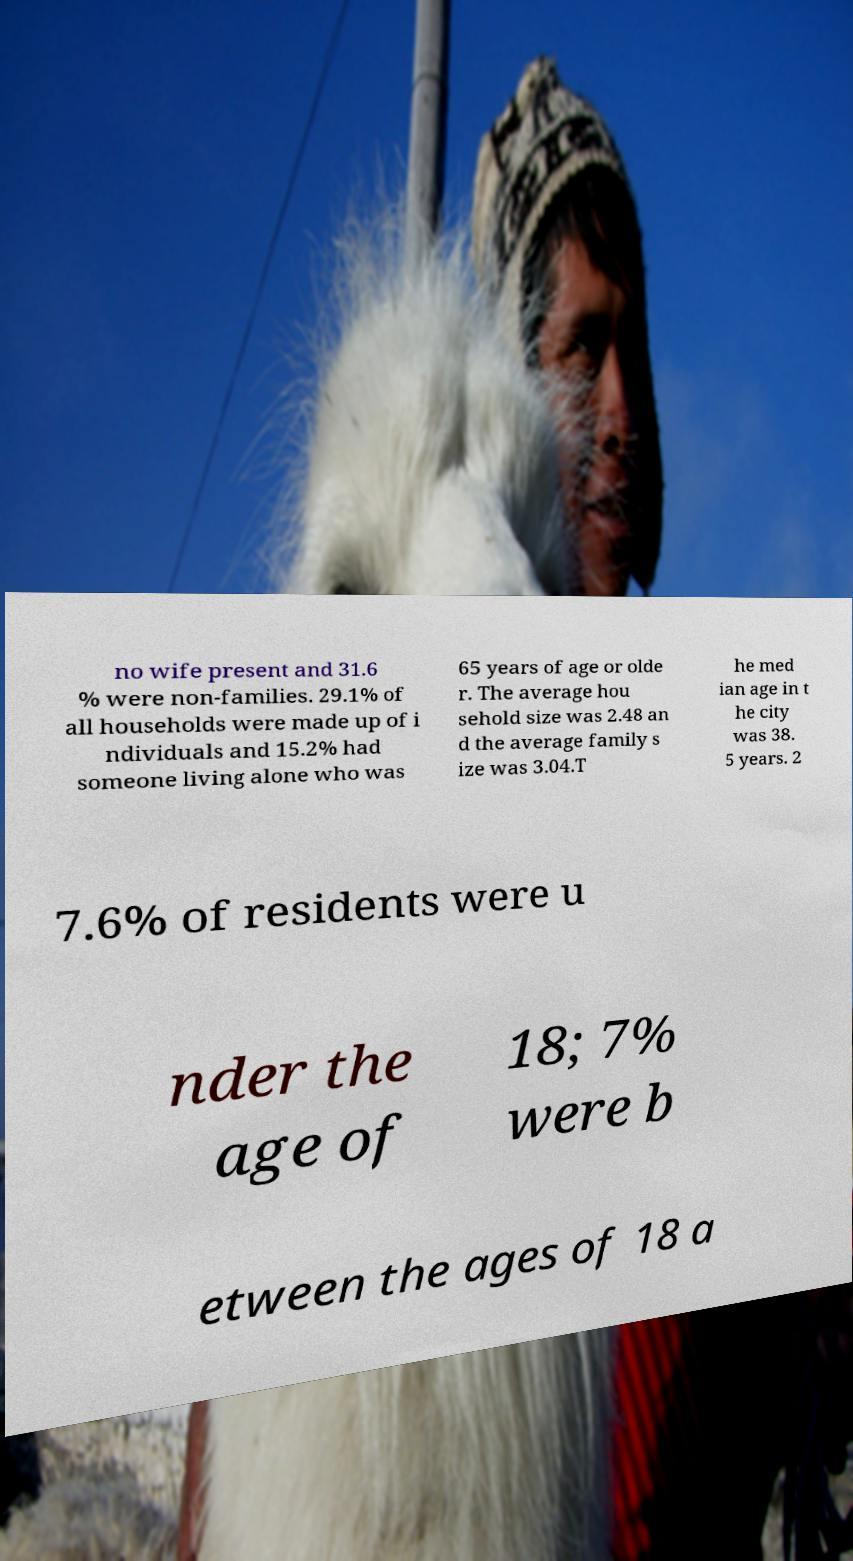Can you accurately transcribe the text from the provided image for me? no wife present and 31.6 % were non-families. 29.1% of all households were made up of i ndividuals and 15.2% had someone living alone who was 65 years of age or olde r. The average hou sehold size was 2.48 an d the average family s ize was 3.04.T he med ian age in t he city was 38. 5 years. 2 7.6% of residents were u nder the age of 18; 7% were b etween the ages of 18 a 